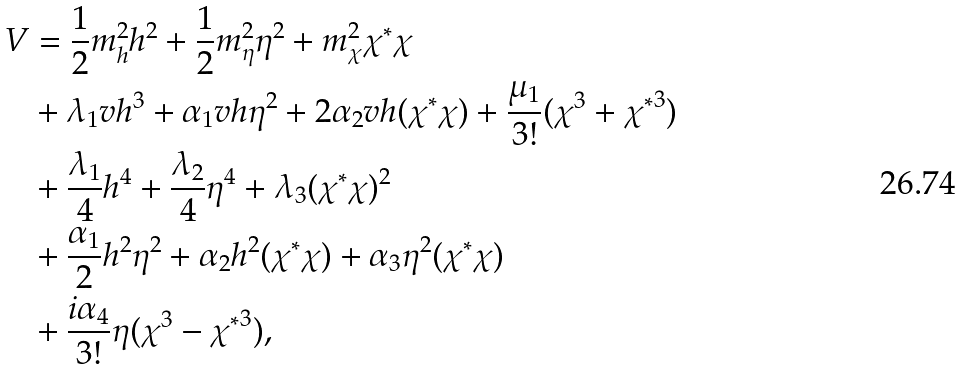<formula> <loc_0><loc_0><loc_500><loc_500>V & = \frac { 1 } { 2 } m _ { h } ^ { 2 } h ^ { 2 } + \frac { 1 } { 2 } m _ { \eta } ^ { 2 } \eta ^ { 2 } + m _ { \chi } ^ { 2 } \chi ^ { * } \chi \\ & + \lambda _ { 1 } v h ^ { 3 } + \alpha _ { 1 } v h \eta ^ { 2 } + 2 \alpha _ { 2 } v h ( \chi ^ { * } \chi ) + \frac { \mu _ { 1 } } { 3 ! } ( \chi ^ { 3 } + { \chi ^ { * } } ^ { 3 } ) \\ & + \frac { \lambda _ { 1 } } { 4 } h ^ { 4 } + \frac { \lambda _ { 2 } } { 4 } \eta ^ { 4 } + \lambda _ { 3 } ( \chi ^ { * } \chi ) ^ { 2 } \\ & + \frac { \alpha _ { 1 } } { 2 } h ^ { 2 } \eta ^ { 2 } + \alpha _ { 2 } h ^ { 2 } ( \chi ^ { * } \chi ) + \alpha _ { 3 } \eta ^ { 2 } ( \chi ^ { * } \chi ) \\ & + \frac { i \alpha _ { 4 } } { 3 ! } \eta ( \chi ^ { 3 } - { \chi ^ { * } } ^ { 3 } ) ,</formula> 